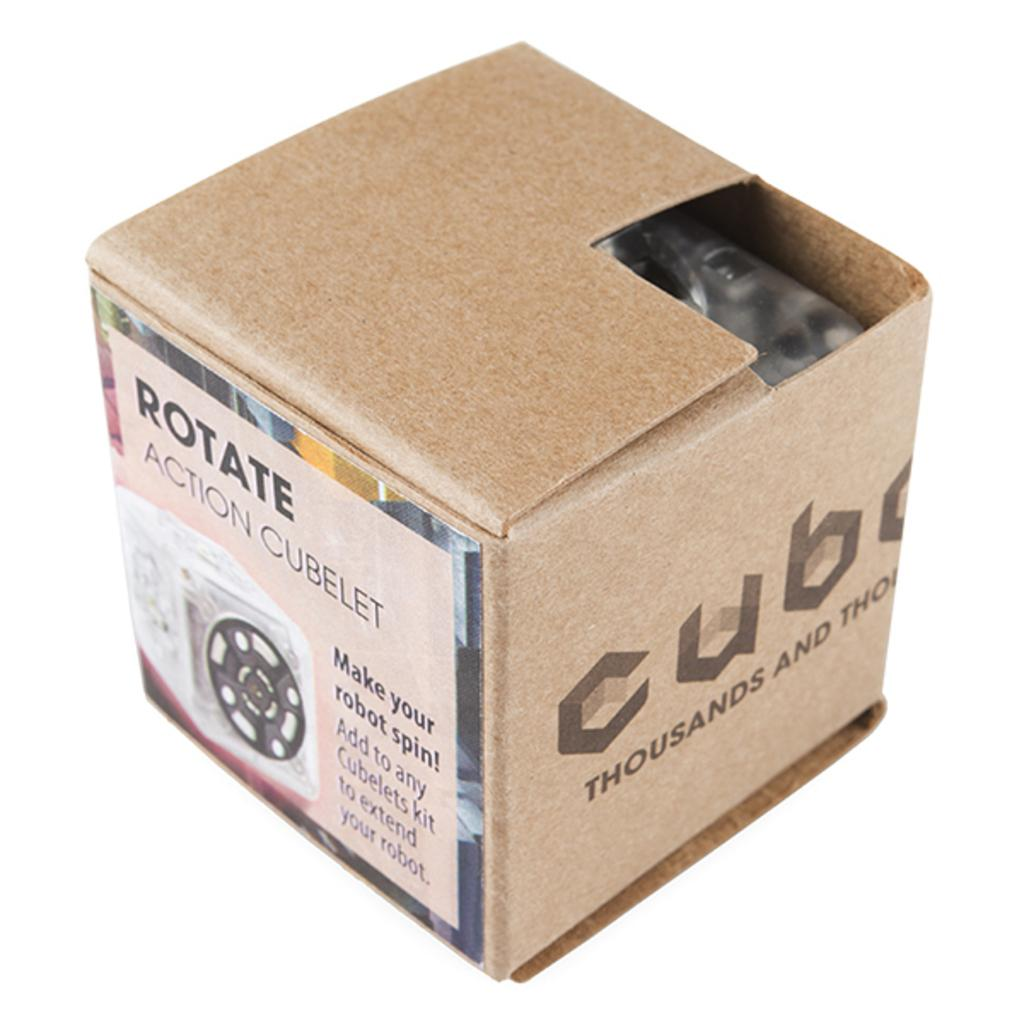What shape is the box in the image? The box in the image is in the shape of a cube. What material is the box made of? The box is made of cardboard. Does the box have any markings or labels? Yes, the box has a label. What information is included on the label? The label includes the name "Rotate action cube let." What type of spring is used to power the cube in the image? There is no spring present in the image, as it features a box with a label. 